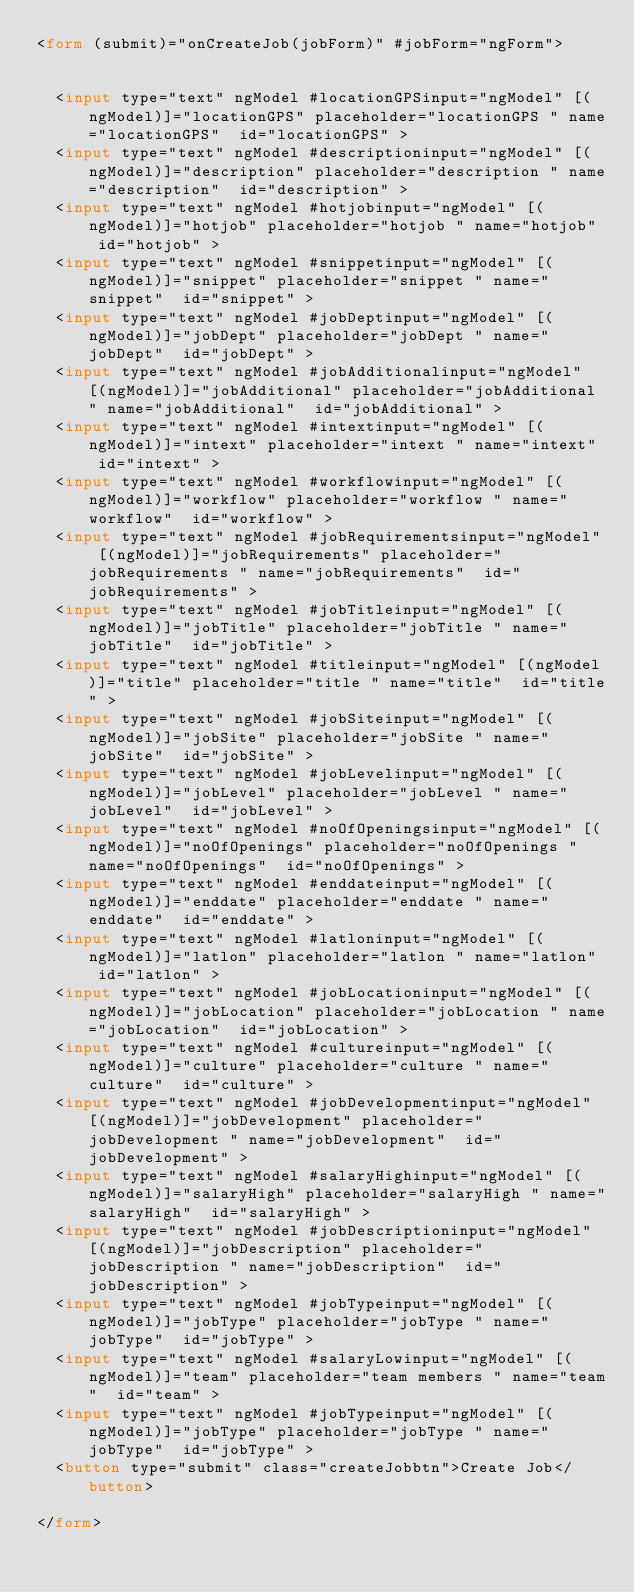<code> <loc_0><loc_0><loc_500><loc_500><_HTML_><form (submit)="onCreateJob(jobForm)" #jobForm="ngForm">


  <input type="text" ngModel #locationGPSinput="ngModel" [(ngModel)]="locationGPS" placeholder="locationGPS " name="locationGPS"  id="locationGPS" >
  <input type="text" ngModel #descriptioninput="ngModel" [(ngModel)]="description" placeholder="description " name="description"  id="description" >
  <input type="text" ngModel #hotjobinput="ngModel" [(ngModel)]="hotjob" placeholder="hotjob " name="hotjob"  id="hotjob" >
  <input type="text" ngModel #snippetinput="ngModel" [(ngModel)]="snippet" placeholder="snippet " name="snippet"  id="snippet" >
  <input type="text" ngModel #jobDeptinput="ngModel" [(ngModel)]="jobDept" placeholder="jobDept " name="jobDept"  id="jobDept" >
  <input type="text" ngModel #jobAdditionalinput="ngModel" [(ngModel)]="jobAdditional" placeholder="jobAdditional " name="jobAdditional"  id="jobAdditional" >
  <input type="text" ngModel #intextinput="ngModel" [(ngModel)]="intext" placeholder="intext " name="intext"  id="intext" >
  <input type="text" ngModel #workflowinput="ngModel" [(ngModel)]="workflow" placeholder="workflow " name="workflow"  id="workflow" >
  <input type="text" ngModel #jobRequirementsinput="ngModel" [(ngModel)]="jobRequirements" placeholder="jobRequirements " name="jobRequirements"  id="jobRequirements" >
  <input type="text" ngModel #jobTitleinput="ngModel" [(ngModel)]="jobTitle" placeholder="jobTitle " name="jobTitle"  id="jobTitle" >
  <input type="text" ngModel #titleinput="ngModel" [(ngModel)]="title" placeholder="title " name="title"  id="title" >
  <input type="text" ngModel #jobSiteinput="ngModel" [(ngModel)]="jobSite" placeholder="jobSite " name="jobSite"  id="jobSite" >
  <input type="text" ngModel #jobLevelinput="ngModel" [(ngModel)]="jobLevel" placeholder="jobLevel " name="jobLevel"  id="jobLevel" >
  <input type="text" ngModel #noOfOpeningsinput="ngModel" [(ngModel)]="noOfOpenings" placeholder="noOfOpenings " name="noOfOpenings"  id="noOfOpenings" >
  <input type="text" ngModel #enddateinput="ngModel" [(ngModel)]="enddate" placeholder="enddate " name="enddate"  id="enddate" >
  <input type="text" ngModel #latloninput="ngModel" [(ngModel)]="latlon" placeholder="latlon " name="latlon"  id="latlon" >
  <input type="text" ngModel #jobLocationinput="ngModel" [(ngModel)]="jobLocation" placeholder="jobLocation " name="jobLocation"  id="jobLocation" >
  <input type="text" ngModel #cultureinput="ngModel" [(ngModel)]="culture" placeholder="culture " name="culture"  id="culture" >
  <input type="text" ngModel #jobDevelopmentinput="ngModel" [(ngModel)]="jobDevelopment" placeholder="jobDevelopment " name="jobDevelopment"  id="jobDevelopment" >
  <input type="text" ngModel #salaryHighinput="ngModel" [(ngModel)]="salaryHigh" placeholder="salaryHigh " name="salaryHigh"  id="salaryHigh" >
  <input type="text" ngModel #jobDescriptioninput="ngModel" [(ngModel)]="jobDescription" placeholder="jobDescription " name="jobDescription"  id="jobDescription" >
  <input type="text" ngModel #jobTypeinput="ngModel" [(ngModel)]="jobType" placeholder="jobType " name="jobType"  id="jobType" >
  <input type="text" ngModel #salaryLowinput="ngModel" [(ngModel)]="team" placeholder="team members " name="team"  id="team" >
  <input type="text" ngModel #jobTypeinput="ngModel" [(ngModel)]="jobType" placeholder="jobType " name="jobType"  id="jobType" >
  <button type="submit" class="createJobbtn">Create Job</button>

</form>
</code> 